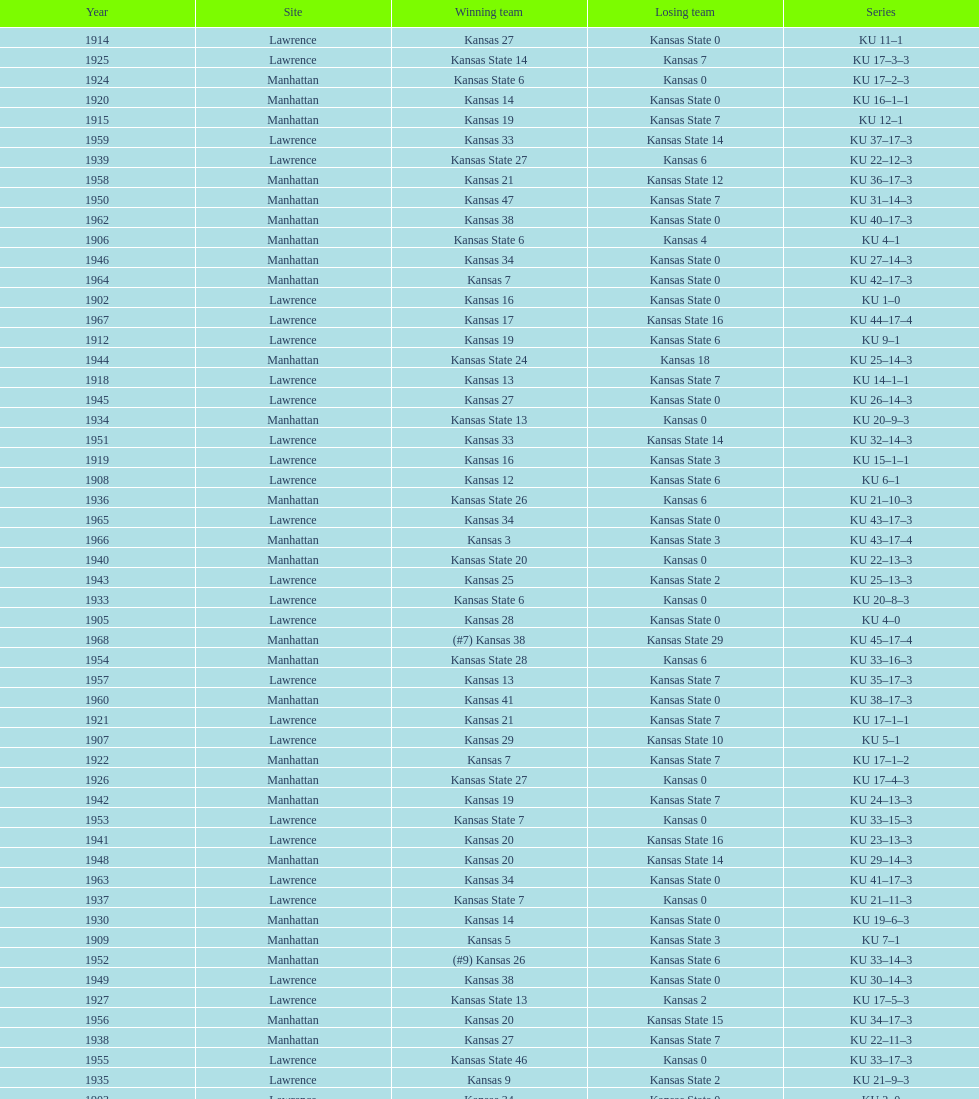When was the last time kansas state lost with 0 points in manhattan? 1964. 